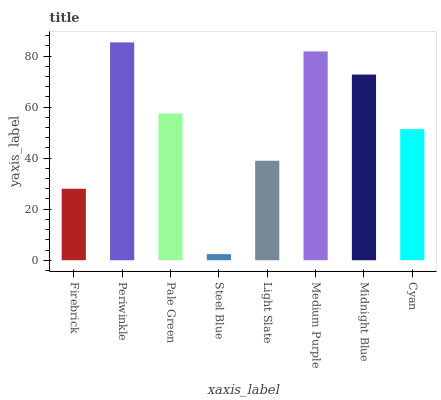Is Steel Blue the minimum?
Answer yes or no. Yes. Is Periwinkle the maximum?
Answer yes or no. Yes. Is Pale Green the minimum?
Answer yes or no. No. Is Pale Green the maximum?
Answer yes or no. No. Is Periwinkle greater than Pale Green?
Answer yes or no. Yes. Is Pale Green less than Periwinkle?
Answer yes or no. Yes. Is Pale Green greater than Periwinkle?
Answer yes or no. No. Is Periwinkle less than Pale Green?
Answer yes or no. No. Is Pale Green the high median?
Answer yes or no. Yes. Is Cyan the low median?
Answer yes or no. Yes. Is Midnight Blue the high median?
Answer yes or no. No. Is Medium Purple the low median?
Answer yes or no. No. 